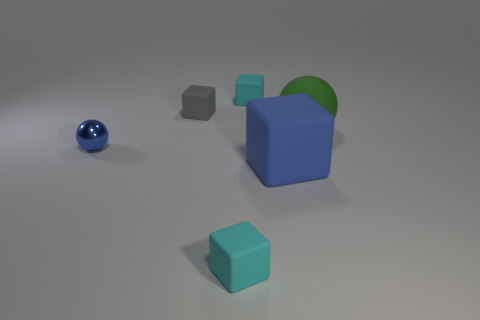Are there the same number of blue rubber objects left of the gray matte object and green rubber balls that are to the right of the small ball?
Ensure brevity in your answer.  No. There is a thing that is left of the small gray rubber block; is its color the same as the big thing that is in front of the tiny blue metal object?
Ensure brevity in your answer.  Yes. Is the number of tiny rubber blocks that are behind the tiny blue shiny sphere greater than the number of large green matte objects?
Provide a short and direct response. Yes. There is a small gray thing that is made of the same material as the large blue cube; what is its shape?
Provide a succinct answer. Cube. Is the size of the blue ball that is on the left side of the rubber ball the same as the gray object?
Provide a short and direct response. Yes. What shape is the tiny object that is on the left side of the tiny gray matte cube on the left side of the large rubber ball?
Keep it short and to the point. Sphere. There is a block to the left of the cyan cube that is in front of the large green matte object; how big is it?
Ensure brevity in your answer.  Small. There is a matte thing in front of the big block; what is its color?
Offer a terse response. Cyan. There is a gray cube that is made of the same material as the large green thing; what is its size?
Your answer should be very brief. Small. What number of green rubber things are the same shape as the shiny object?
Ensure brevity in your answer.  1. 